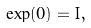Convert formula to latex. <formula><loc_0><loc_0><loc_500><loc_500>\exp ( 0 ) = I ,</formula> 